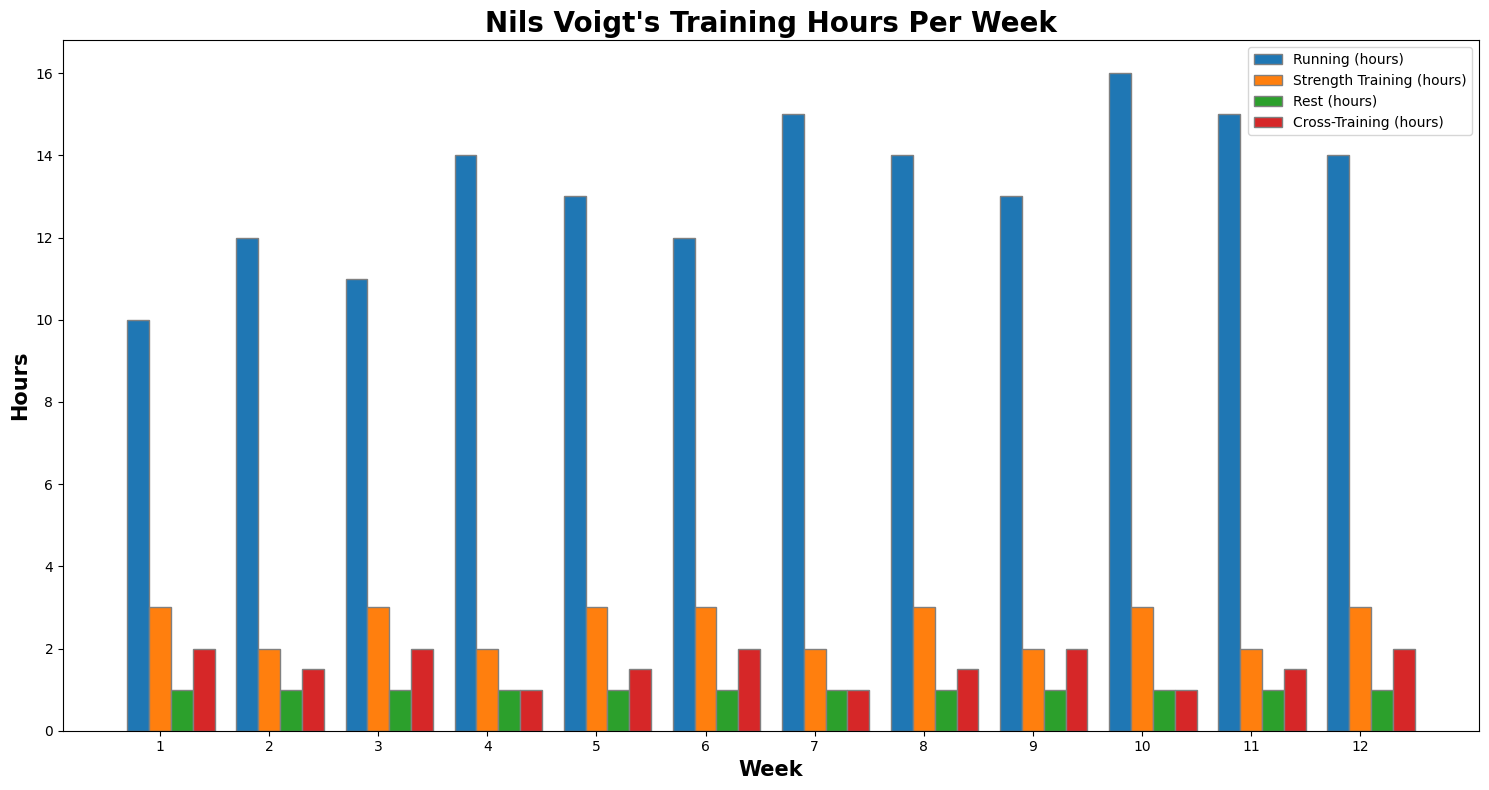Which week had the most hours of running? Look at the heights of the blue bars in each week. The tallest blue bar corresponds to week 10
Answer: Week 10 Which two weeks have equal hours of strength training? Observe the height of the orange bars and compare them across different weeks. Weeks 2 and 4 both have 2 hours of strength training
Answer: Weeks 2 and 4 In which week did Nils Voigt spend the least amount of time cross-training, and how many hours did he spend? Compare all the red bars' heights. The smallest red bar corresponds to week 4 with 1 hour of cross-training
Answer: Week 4, 1 hour Calculate the total training hours (sum of running, strength training, and cross-training) in week 6. Add the running, strength training, and cross-training hours for week 6: 12 + 3 + 2
Answer: 17 hours By how many hours did the running hours in week 5 exceed those in week 3? Subtract the running hours in week 3 from those in week 5: 13 - 11
Answer: 2 hours Compare the total time spent on running and strength training in week 1 and week 8. Which week had higher total training hours and by how much? Sum running and strength training for week 1 (10 + 3 = 13) and week 8 (14 + 3 = 17). Week 8 had more training hours by 4 hours
Answer: Week 8, 4 hours What is the average number of running hours per week over the 12-week period? Add the running hours for all weeks and divide by 12. Sum is 169, so 169 / 12
Answer: 14.08 hours Was there any week where Nils Voigt spent equal hours on running and cross-training? Compare the blue and red bars for each week. No, all weeks have different values for running and cross-training
Answer: No In which weeks did Nils Voigt rest exactly 1 hour? Look at the green bars representing rest hours. All weeks have a 1-hour rest component
Answer: All weeks If you sum the strength training hours for all weeks, what is the total? Add the strength training hours for each week: 3 + 2 + 3 + 2 + 3 + 3 + 2 + 3 + 2 + 3 + 2 + 3 = 31
Answer: 31 hours 